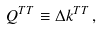<formula> <loc_0><loc_0><loc_500><loc_500>Q ^ { T T } \equiv \Delta k ^ { T T } \, ,</formula> 